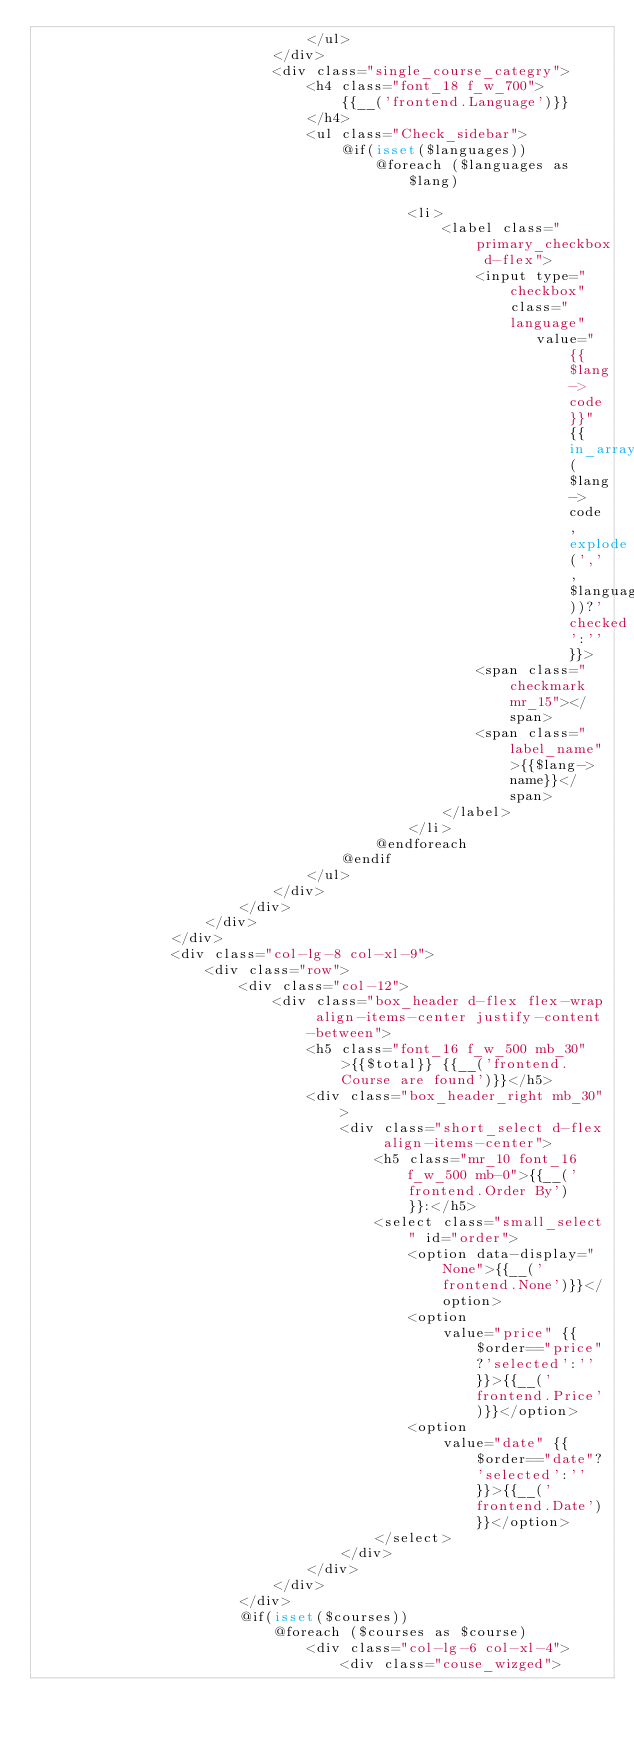<code> <loc_0><loc_0><loc_500><loc_500><_PHP_>                                </ul>
                            </div>
                            <div class="single_course_categry">
                                <h4 class="font_18 f_w_700">
                                    {{__('frontend.Language')}}
                                </h4>
                                <ul class="Check_sidebar">
                                    @if(isset($languages))
                                        @foreach ($languages as $lang)

                                            <li>
                                                <label class="primary_checkbox d-flex">
                                                    <input type="checkbox" class="language"
                                                           value="{{$lang->code}}" {{in_array($lang->code,explode(',',$language))?'checked':''}}>
                                                    <span class="checkmark mr_15"></span>
                                                    <span class="label_name">{{$lang->name}}</span>
                                                </label>
                                            </li>
                                        @endforeach
                                    @endif
                                </ul>
                            </div>
                        </div>
                    </div>
                </div>
                <div class="col-lg-8 col-xl-9">
                    <div class="row">
                        <div class="col-12">
                            <div class="box_header d-flex flex-wrap align-items-center justify-content-between">
                                <h5 class="font_16 f_w_500 mb_30">{{$total}} {{__('frontend.Course are found')}}</h5>
                                <div class="box_header_right mb_30">
                                    <div class="short_select d-flex align-items-center">
                                        <h5 class="mr_10 font_16 f_w_500 mb-0">{{__('frontend.Order By')}}:</h5>
                                        <select class="small_select" id="order">
                                            <option data-display="None">{{__('frontend.None')}}</option>
                                            <option
                                                value="price" {{$order=="price"?'selected':''}}>{{__('frontend.Price')}}</option>
                                            <option
                                                value="date" {{$order=="date"?'selected':''}}>{{__('frontend.Date')}}</option>
                                        </select>
                                    </div>
                                </div>
                            </div>
                        </div>
                        @if(isset($courses))
                            @foreach ($courses as $course)
                                <div class="col-lg-6 col-xl-4">
                                    <div class="couse_wizged"></code> 